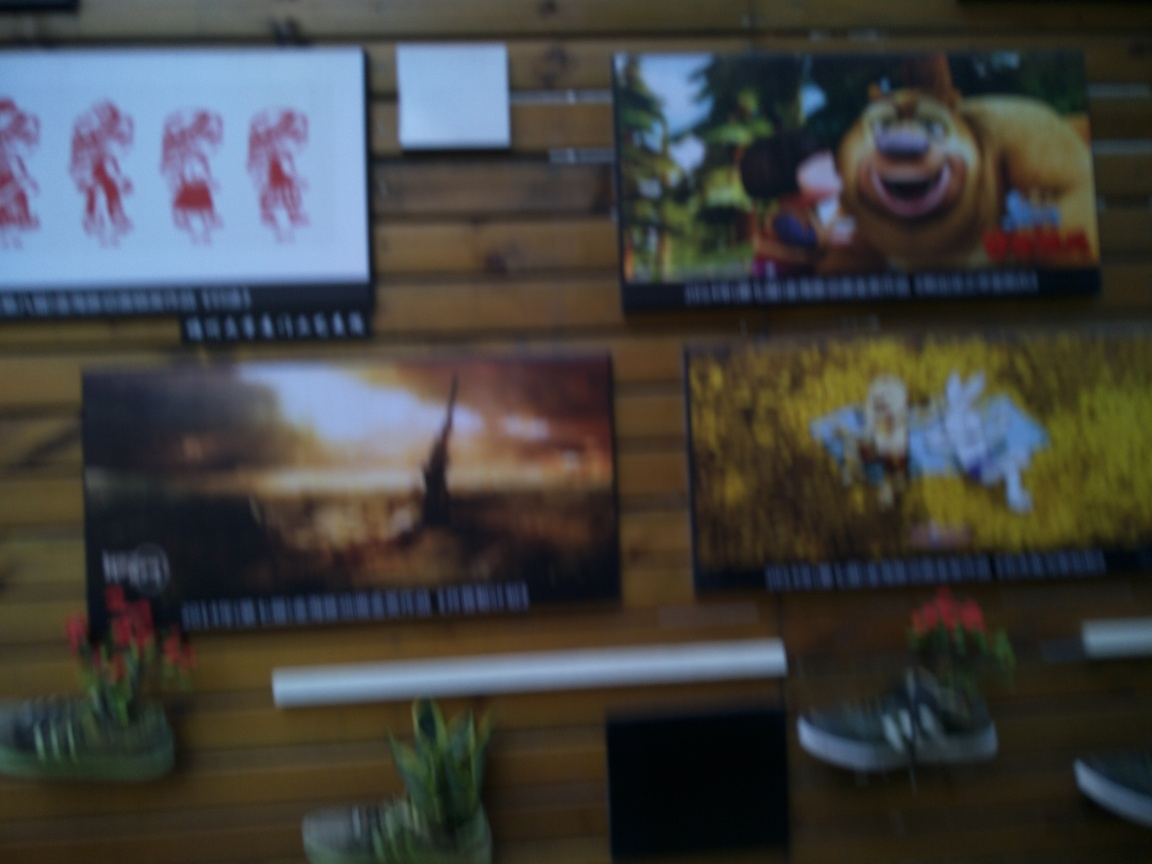Can you describe the type of pictures or posters that seem to be on the wall? The image shows a collection of pictures displayed on a wall, but due to the blurriness, it is not possible to describe them in detail. Generally, there appears to be a mix of artwork or possibly movie posters. These could be showcasing scenes, characters, or artistic creations, commonly found decorating spaces like rooms or hallways for aesthetic or entertainment purposes. 